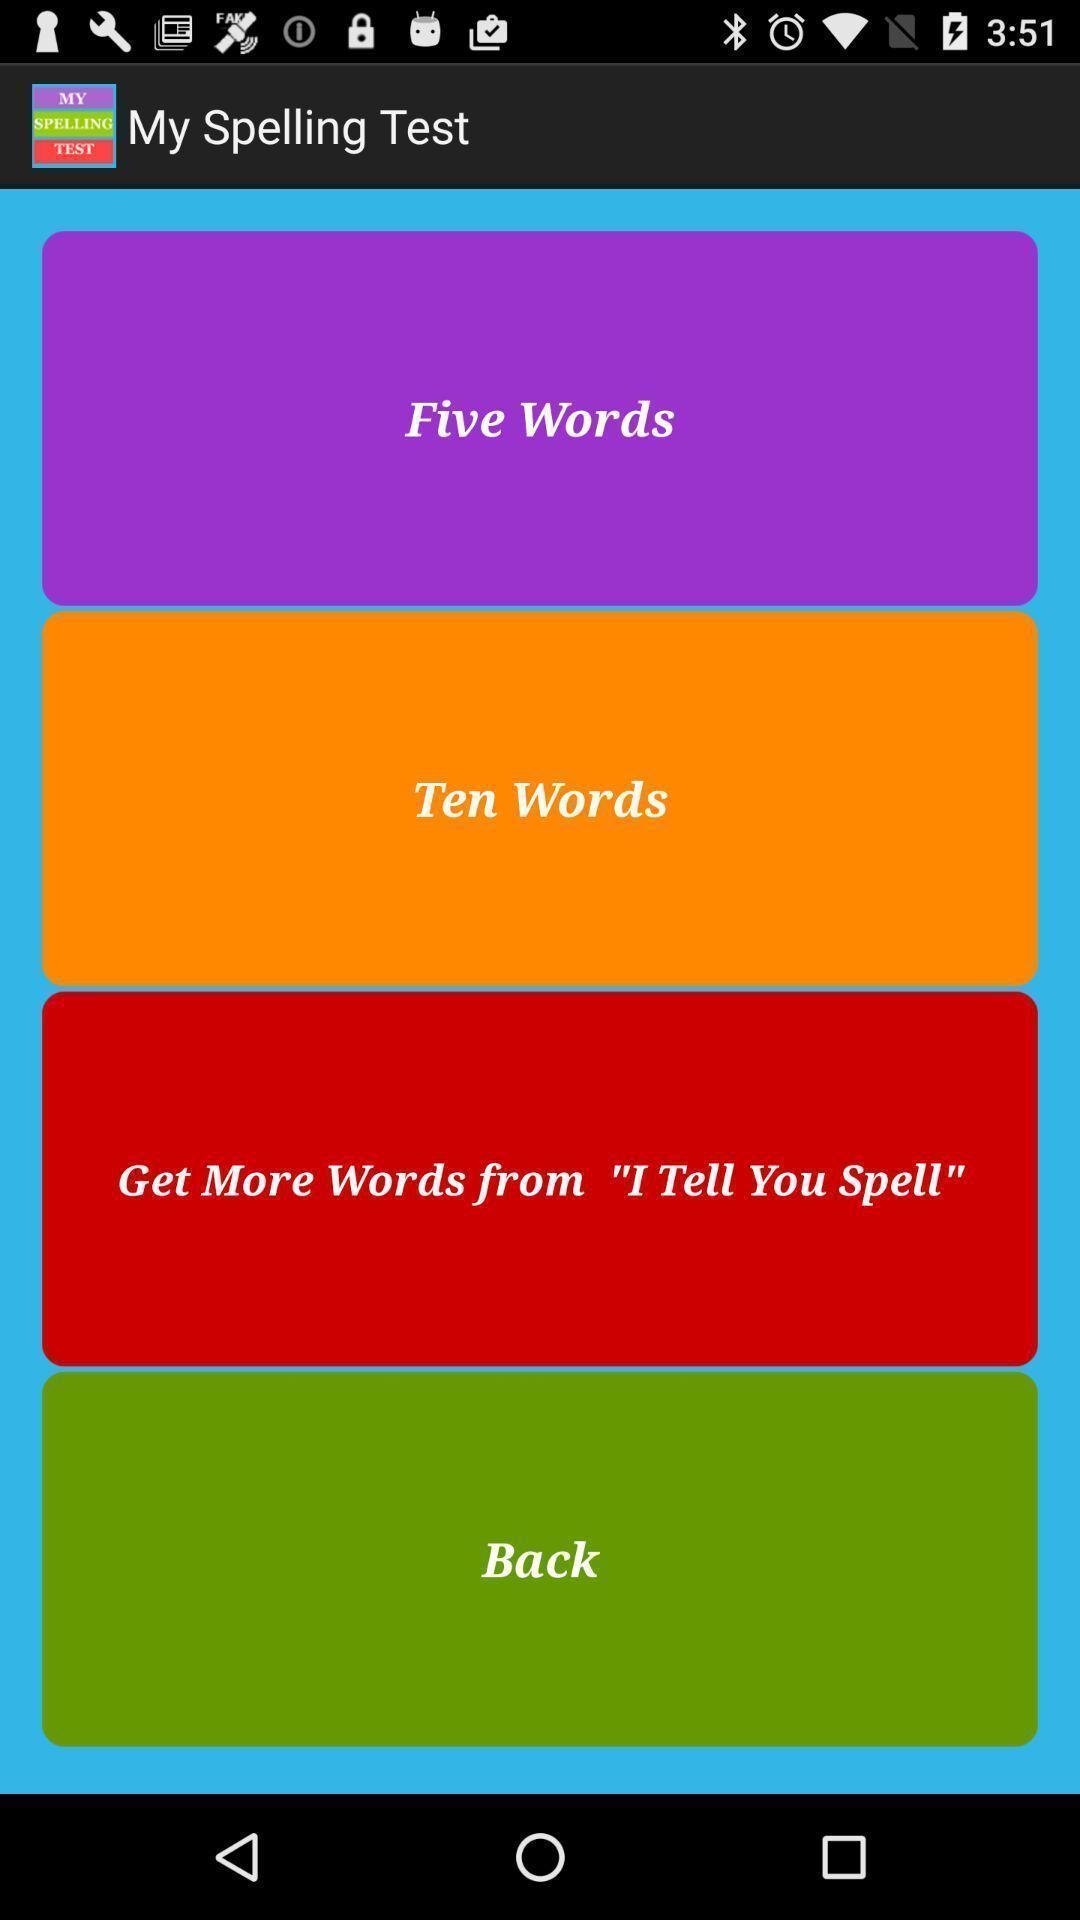Describe this image in words. To learn spellings in this application. 